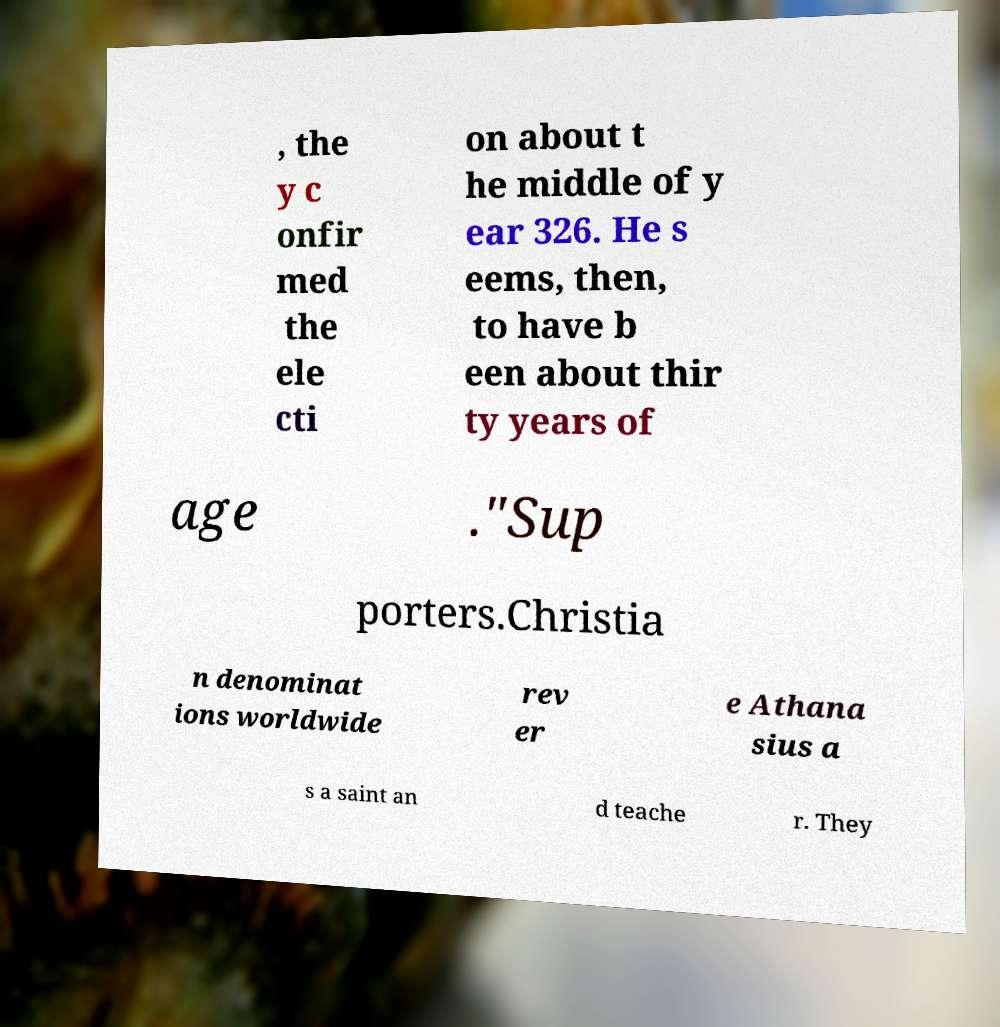I need the written content from this picture converted into text. Can you do that? , the y c onfir med the ele cti on about t he middle of y ear 326. He s eems, then, to have b een about thir ty years of age ."Sup porters.Christia n denominat ions worldwide rev er e Athana sius a s a saint an d teache r. They 